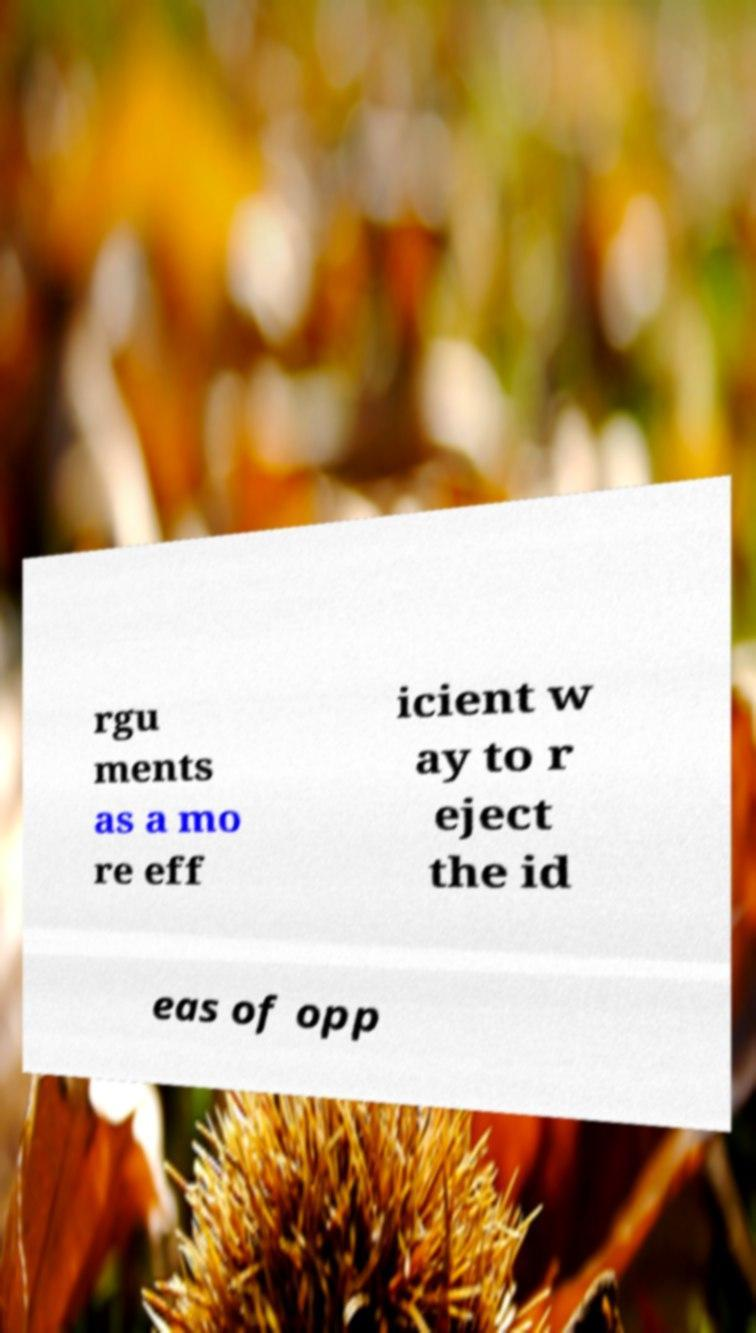What messages or text are displayed in this image? I need them in a readable, typed format. rgu ments as a mo re eff icient w ay to r eject the id eas of opp 